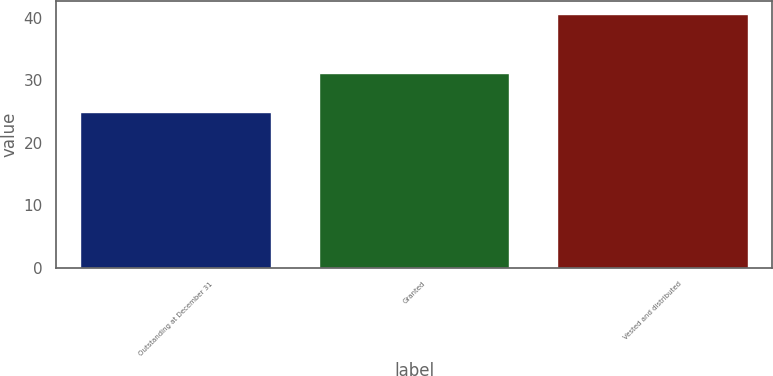<chart> <loc_0><loc_0><loc_500><loc_500><bar_chart><fcel>Outstanding at December 31<fcel>Granted<fcel>Vested and distributed<nl><fcel>24.86<fcel>31.15<fcel>40.63<nl></chart> 